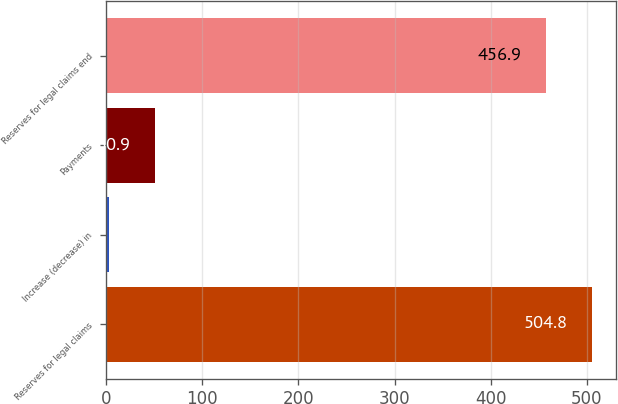Convert chart to OTSL. <chart><loc_0><loc_0><loc_500><loc_500><bar_chart><fcel>Reserves for legal claims<fcel>Increase (decrease) in<fcel>Payments<fcel>Reserves for legal claims end<nl><fcel>504.8<fcel>3<fcel>50.9<fcel>456.9<nl></chart> 